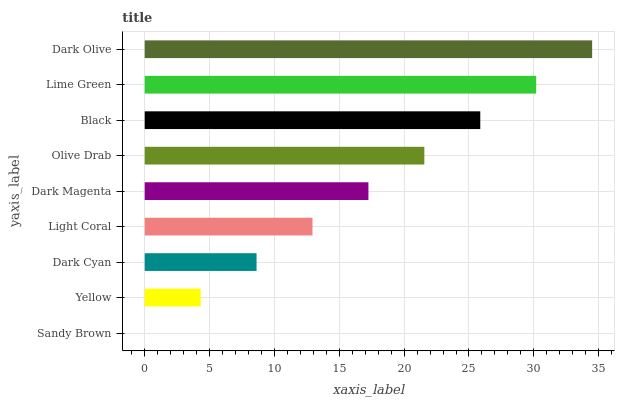Is Sandy Brown the minimum?
Answer yes or no. Yes. Is Dark Olive the maximum?
Answer yes or no. Yes. Is Yellow the minimum?
Answer yes or no. No. Is Yellow the maximum?
Answer yes or no. No. Is Yellow greater than Sandy Brown?
Answer yes or no. Yes. Is Sandy Brown less than Yellow?
Answer yes or no. Yes. Is Sandy Brown greater than Yellow?
Answer yes or no. No. Is Yellow less than Sandy Brown?
Answer yes or no. No. Is Dark Magenta the high median?
Answer yes or no. Yes. Is Dark Magenta the low median?
Answer yes or no. Yes. Is Dark Cyan the high median?
Answer yes or no. No. Is Olive Drab the low median?
Answer yes or no. No. 